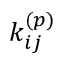Convert formula to latex. <formula><loc_0><loc_0><loc_500><loc_500>k _ { i j } ^ { ( p ) }</formula> 